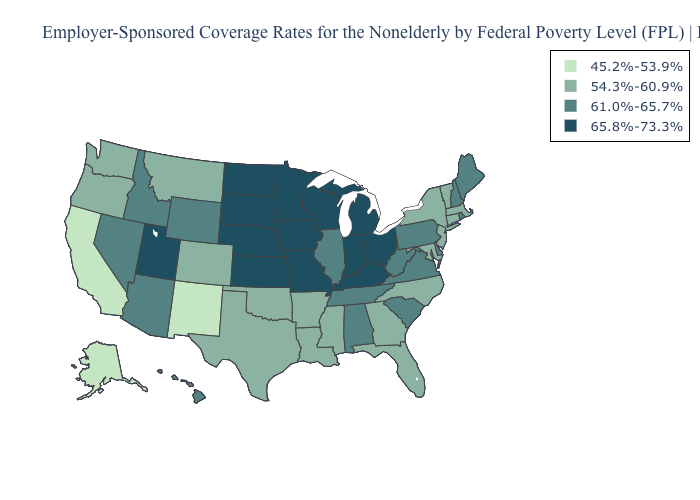What is the value of Nebraska?
Answer briefly. 65.8%-73.3%. What is the value of Indiana?
Give a very brief answer. 65.8%-73.3%. Name the states that have a value in the range 61.0%-65.7%?
Short answer required. Alabama, Arizona, Delaware, Hawaii, Idaho, Illinois, Maine, Nevada, New Hampshire, Pennsylvania, Rhode Island, South Carolina, Tennessee, Virginia, West Virginia, Wyoming. What is the value of Wisconsin?
Quick response, please. 65.8%-73.3%. What is the highest value in the South ?
Concise answer only. 65.8%-73.3%. Does Alabama have the lowest value in the South?
Write a very short answer. No. What is the value of Texas?
Concise answer only. 54.3%-60.9%. What is the value of Connecticut?
Answer briefly. 54.3%-60.9%. What is the lowest value in the USA?
Give a very brief answer. 45.2%-53.9%. Which states have the lowest value in the MidWest?
Quick response, please. Illinois. Name the states that have a value in the range 61.0%-65.7%?
Quick response, please. Alabama, Arizona, Delaware, Hawaii, Idaho, Illinois, Maine, Nevada, New Hampshire, Pennsylvania, Rhode Island, South Carolina, Tennessee, Virginia, West Virginia, Wyoming. Among the states that border South Dakota , does Minnesota have the lowest value?
Quick response, please. No. What is the lowest value in the USA?
Give a very brief answer. 45.2%-53.9%. Which states have the highest value in the USA?
Answer briefly. Indiana, Iowa, Kansas, Kentucky, Michigan, Minnesota, Missouri, Nebraska, North Dakota, Ohio, South Dakota, Utah, Wisconsin. Does Rhode Island have the lowest value in the Northeast?
Quick response, please. No. 